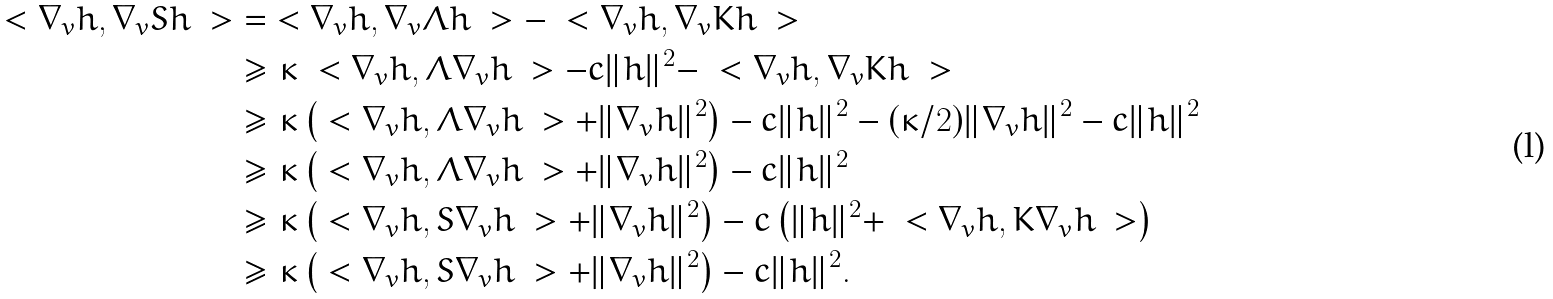Convert formula to latex. <formula><loc_0><loc_0><loc_500><loc_500>\ < \nabla _ { v } h , \nabla _ { v } S h \ > & = \ < \nabla _ { v } h , \nabla _ { v } \Lambda h \ > - \ < \nabla _ { v } h , \nabla _ { v } K h \ > \\ & \geq \kappa \ < \nabla _ { v } h , \Lambda \nabla _ { v } h \ > - c \| h \| ^ { 2 } - \ < \nabla _ { v } h , \nabla _ { v } K h \ > \\ & \geq \kappa \left ( \ < \nabla _ { v } h , \Lambda \nabla _ { v } h \ > + \| \nabla _ { v } h \| ^ { 2 } \right ) - c \| h \| ^ { 2 } - ( \kappa / 2 ) \| \nabla _ { v } h \| ^ { 2 } - c \| h \| ^ { 2 } \\ & \geq \kappa \left ( \ < \nabla _ { v } h , \Lambda \nabla _ { v } h \ > + \| \nabla _ { v } h \| ^ { 2 } \right ) - c \| h \| ^ { 2 } \\ & \geq \kappa \left ( \ < \nabla _ { v } h , S \nabla _ { v } h \ > + \| \nabla _ { v } h \| ^ { 2 } \right ) - c \left ( \| h \| ^ { 2 } + \ < \nabla _ { v } h , K \nabla _ { v } h \ > \right ) \\ & \geq \kappa \left ( \ < \nabla _ { v } h , S \nabla _ { v } h \ > + \| \nabla _ { v } h \| ^ { 2 } \right ) - c \| h \| ^ { 2 } .</formula> 